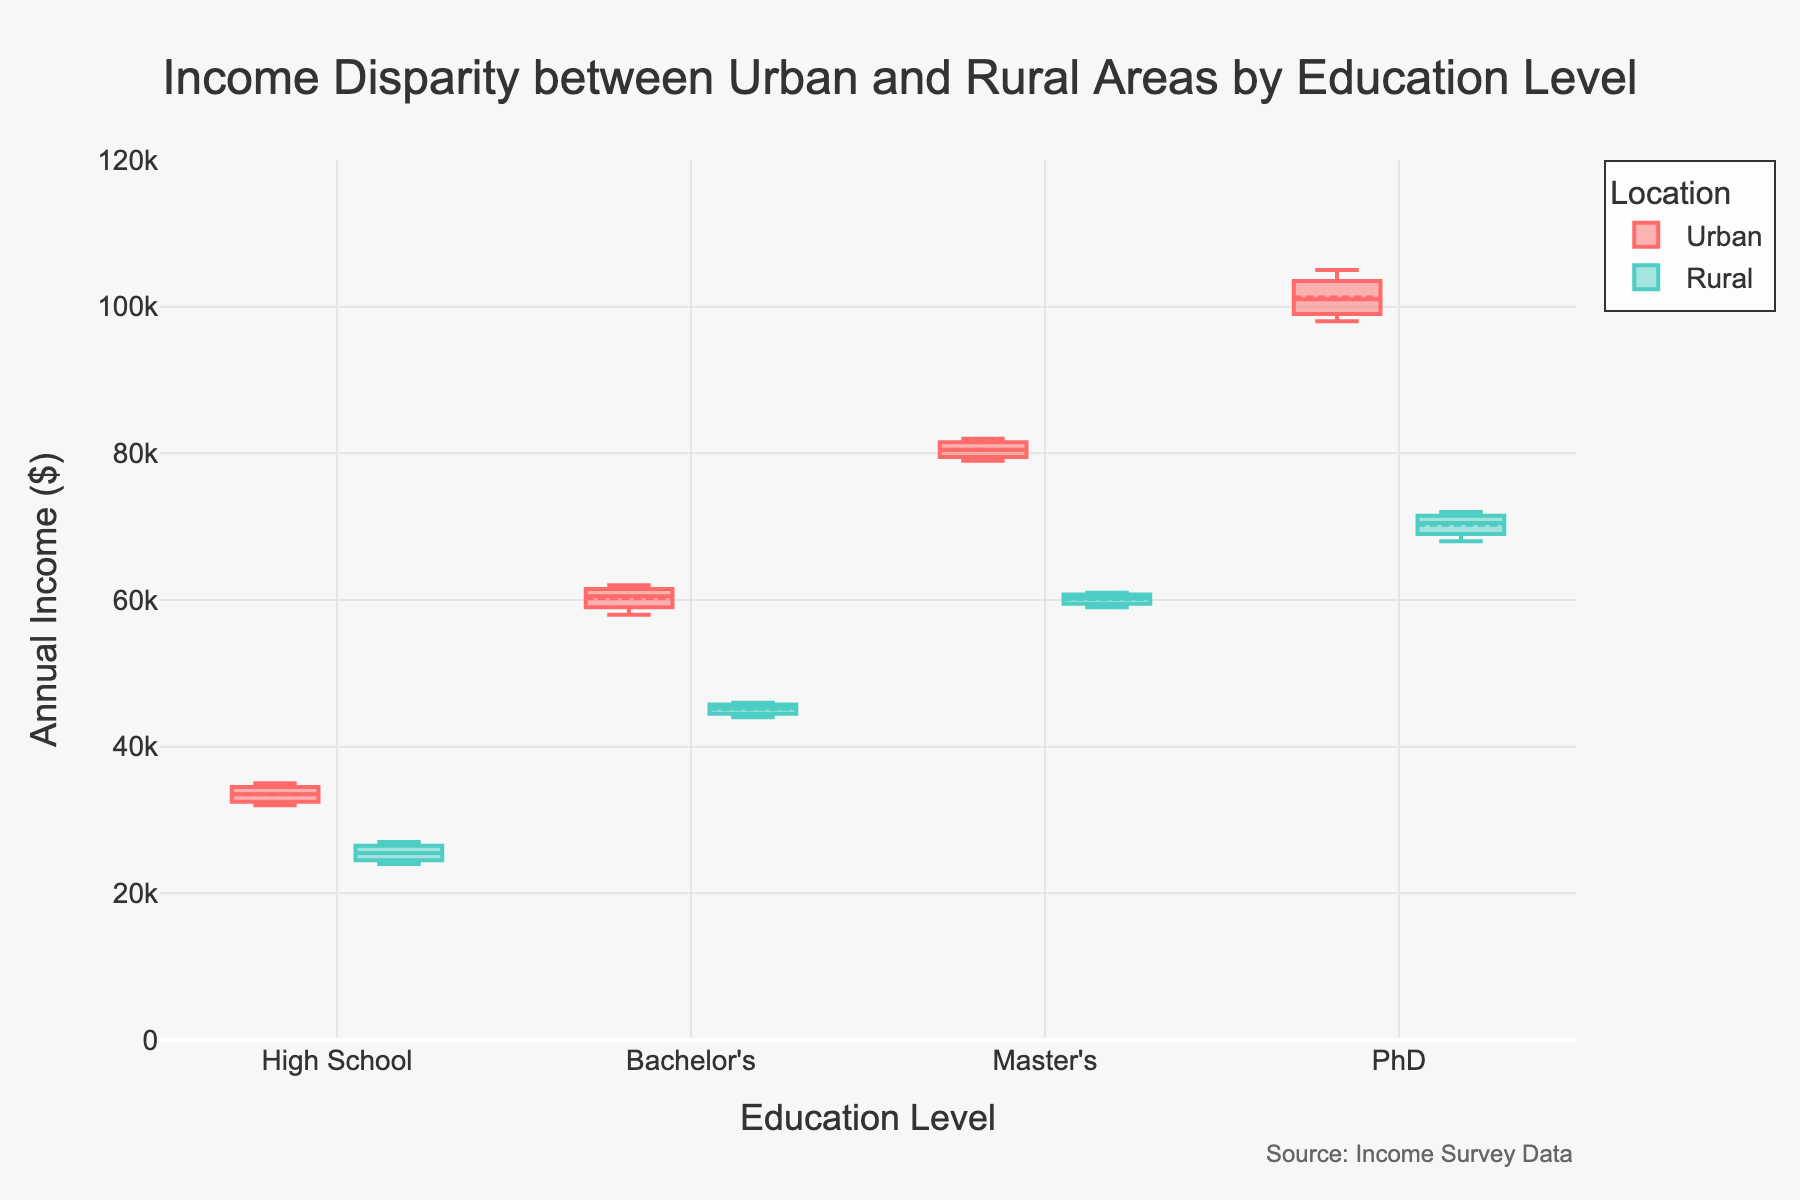What's the title of the figure? The title of a figure typically appears at the top. It provides a summary of what the figure represents. In this case, the title is "Income Disparity between Urban and Rural Areas by Education Level."
Answer: Income Disparity between Urban and Rural Areas by Education Level What are the two categories compared in the figure? The figure uses color to differentiate between two categories. These categories are denoted by the legend which is labeled "Location." The two categories are "Urban" and "Rural."
Answer: Urban and Rural What is the y-axis representing? The y-axis label gives the unit of measurement or what is being measured. Here, the y-axis label is "Annual Income ($)," indicating that it represents the annual income in dollars.
Answer: Annual Income ($) How does the median income of individuals with a PhD in urban areas compare to those in rural areas? The median line in each box plot shows the median value. For PhD holders, the median line in the urban box plot is higher on the y-axis compared to that in the rural box plot, indicating a higher median income.
Answer: Higher Which education level shows the greatest income disparity between urban and rural areas? Income disparity is visible by examining the difference in the y-axis values between the urban and rural box plots for each education level. The PhD level shows the widest gap between urban and rural median incomes, suggesting the greatest disparity.
Answer: PhD What's the average income for individuals with a Bachelor's degree in urban areas? The box plot's boxmean property displays a small line indicating the mean value within each box. For the Bachelor's degree in urban settings, this mark is around the y-axis value of 60,000.
Answer: 60,000 Do individuals with a Master's degree in rural areas earn more on average than those with a Bachelor's degree in urban areas? By comparing the mean markers, individuals with a Master's degree in rural areas (around 60,000) have a similar average income to those with a Bachelor's degree in urban areas (also around 60,000). However, the question specifies "more," so they do not earn more.
Answer: No What range of incomes is represented by the interquartile range (IQR) for individuals with a Master's degree in urban areas? The IQR is represented by the height of the box in the box plot. For those with a Master's degree in urban areas, the box extends approximately between the values 79,000 and 82,000.
Answer: 79,000 to 82,000 How does the variability of income differ between urban and rural areas for individuals with a high school education? The variability in income can be inferred from the spread of the box plots. For high school education, the urban box plot is slightly more spread out along the y-axis than the rural box plot, indicating higher variability in urban high school incomes.
Answer: Higher in Urban 